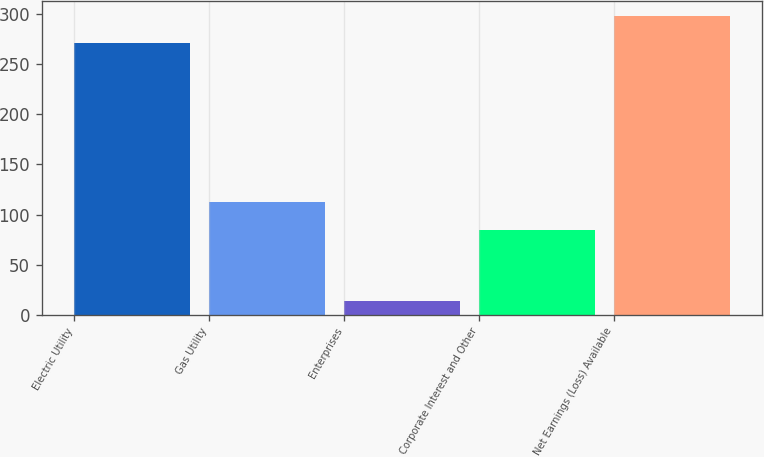Convert chart. <chart><loc_0><loc_0><loc_500><loc_500><bar_chart><fcel>Electric Utility<fcel>Gas Utility<fcel>Enterprises<fcel>Corporate Interest and Other<fcel>Net Earnings (Loss) Available<nl><fcel>271<fcel>112.5<fcel>14<fcel>85<fcel>298.5<nl></chart> 